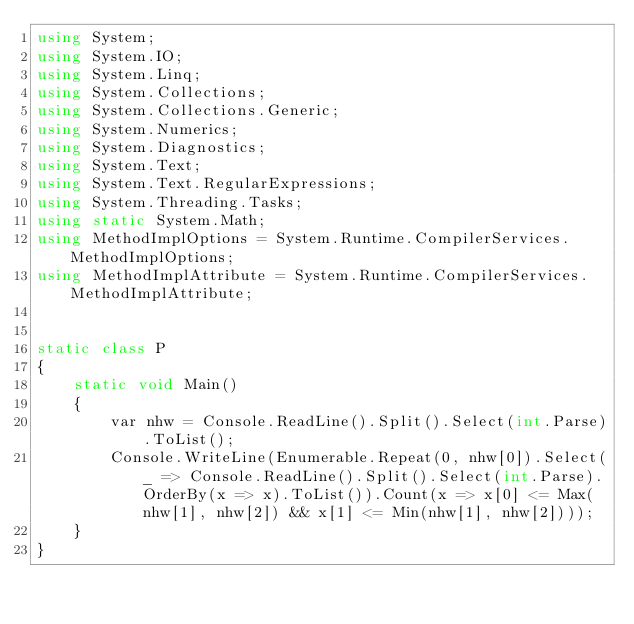<code> <loc_0><loc_0><loc_500><loc_500><_C#_>using System;
using System.IO;
using System.Linq;
using System.Collections;
using System.Collections.Generic;
using System.Numerics;
using System.Diagnostics;
using System.Text;
using System.Text.RegularExpressions;
using System.Threading.Tasks;
using static System.Math;
using MethodImplOptions = System.Runtime.CompilerServices.MethodImplOptions;
using MethodImplAttribute = System.Runtime.CompilerServices.MethodImplAttribute;


static class P
{
    static void Main()
    {
        var nhw = Console.ReadLine().Split().Select(int.Parse).ToList();
        Console.WriteLine(Enumerable.Repeat(0, nhw[0]).Select(_ => Console.ReadLine().Split().Select(int.Parse).OrderBy(x => x).ToList()).Count(x => x[0] <= Max(nhw[1], nhw[2]) && x[1] <= Min(nhw[1], nhw[2])));
    }
}</code> 